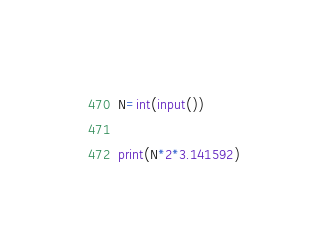<code> <loc_0><loc_0><loc_500><loc_500><_Python_>N=int(input())

print(N*2*3.141592)</code> 